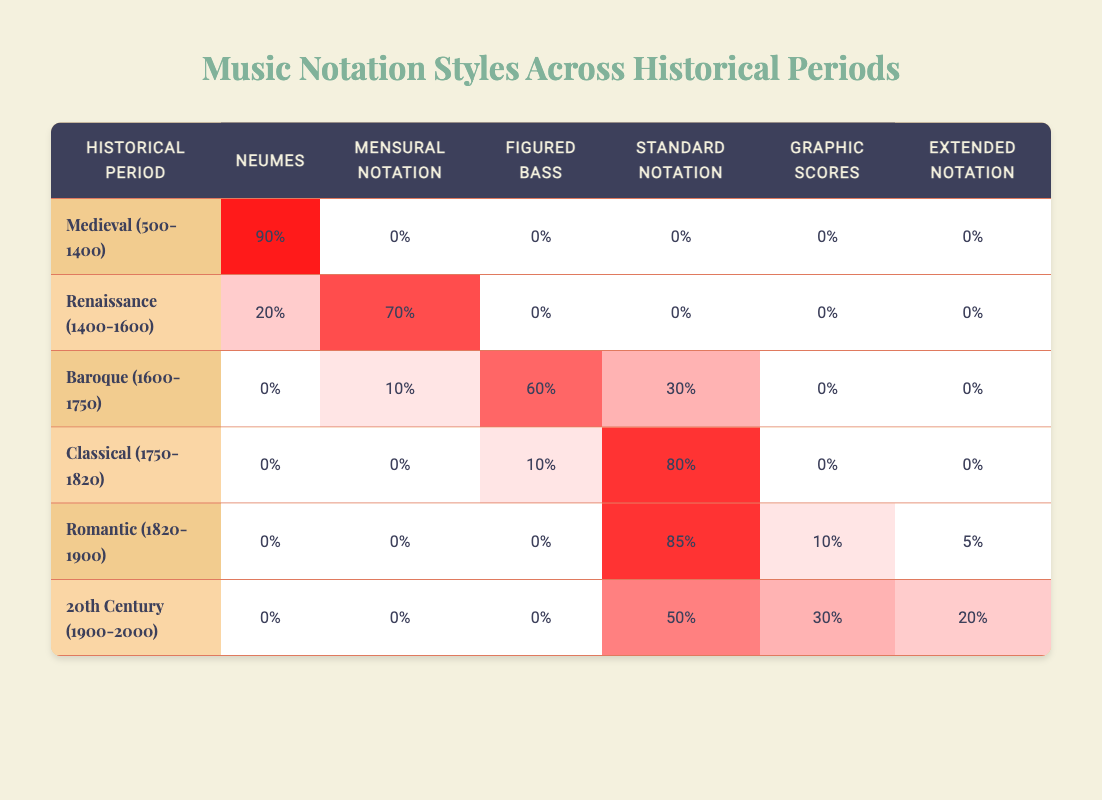What is the percentage of Neumes used in the Medieval period? Looking at the table, the percentage of Neumes in the Medieval (500-1400) row shows 90%.
Answer: 90% Which notation style had the highest usage in the Renaissance period? The Renaissance row indicates that Mensural Notation has the highest usage at 70%, as it is the only value in that period with a significant amount.
Answer: Mensural Notation What is the total usage of Standard Notation across all periods? We check each period and find the percentages: Classical period (80%), Romantic period (85%), and 20th Century (50%). Summing these gives 80 + 85 + 50 = 215.
Answer: 215 Is there any period that primarily used Graphic Scores? In the table, the only period that has a significant amount for Graphic Scores is the Romantic period at 10%, while others show 0%. Therefore, there is no primary usage of Graphic Scores in any period.
Answer: No What is the difference in usage between Figured Bass in the Baroque and Classical periods? The usage of Figured Bass in the Baroque period is 60% and in the Classical period is 10%. The difference is calculated as 60 - 10 = 50%.
Answer: 50% Which historical period shows an increase in the diversity of notation styles based on the table? In the table, the Baroque period includes four notation styles (Mensural Notation, Figured Bass, Standard Notation, and Neumes), whereas earlier periods have fewer styles. By examining the counts, we find the Baroque period is the only one with significant diversity.
Answer: Baroque (1600-1750) How many percentages of notation styles were unused in the Romantic period? In the Romantic period, there are 0% for Neumes, Mensural Notation, and Figured Bass, totaling 0 + 0 + 0 = 0%. However, Graphic Scores and Extended Notation have some percentage, indicating only two unused styles of Neumes and Mensural.
Answer: 3 Which period had more usage of Mensural Notation: Renaissance or Baroque? In the table, the Renaissance period shows 70% usage of Mensural Notation while the Baroque period shows 10%. Therefore, Renaissance outperforms Baroque in Mensural usage.
Answer: Renaissance (1400-1600) What percentage of Standard Notation was used compared to all notations in the 20th Century? The 20th Century shows 50% for Standard Notation, while the total percentages for other notations are 30% for Graphic Scores and 20% for Extended Notation. The total for this period counts as 50 + 30 + 20 = 100%, so Standard Notation's ratio is 50/100 = 50%.
Answer: 50% 